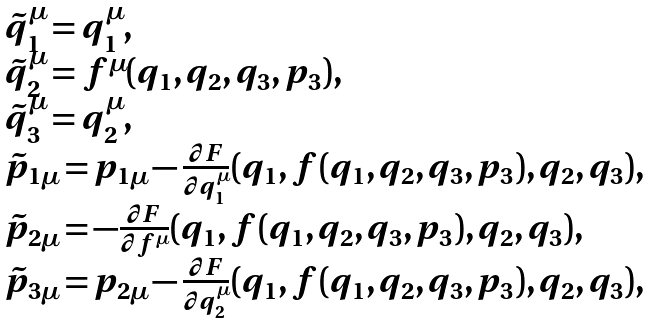Convert formula to latex. <formula><loc_0><loc_0><loc_500><loc_500>\begin{array} { l } \tilde { q } _ { 1 } ^ { \mu } = q _ { 1 } ^ { \mu } , \\ \tilde { q } _ { 2 } ^ { \mu } = f ^ { \mu } ( q _ { 1 } , q _ { 2 } , q _ { 3 } , p _ { 3 } ) , \\ \tilde { q } _ { 3 } ^ { \mu } = q _ { 2 } ^ { \mu } , \\ \tilde { p } _ { 1 \mu } = p _ { 1 \mu } - \frac { \partial F } { \partial q _ { 1 } ^ { \mu } } ( q _ { 1 } , f ( q _ { 1 } , q _ { 2 } , q _ { 3 } , p _ { 3 } ) , q _ { 2 } , q _ { 3 } ) , \\ \tilde { p } _ { 2 \mu } = - \frac { \partial F } { \partial f ^ { \mu } } ( q _ { 1 } , f ( q _ { 1 } , q _ { 2 } , q _ { 3 } , p _ { 3 } ) , q _ { 2 } , q _ { 3 } ) , \\ \tilde { p } _ { 3 \mu } = p _ { 2 \mu } - \frac { \partial F } { \partial q _ { 2 } ^ { \mu } } ( q _ { 1 } , f ( q _ { 1 } , q _ { 2 } , q _ { 3 } , p _ { 3 } ) , q _ { 2 } , q _ { 3 } ) , \\ \end{array}</formula> 